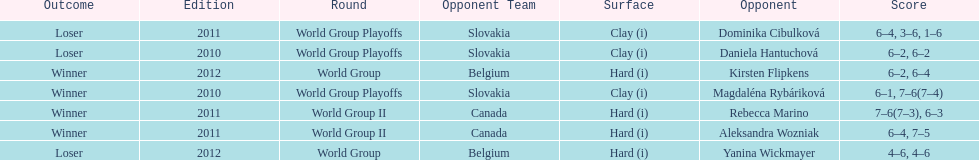What is the other year slovakia played besides 2010? 2011. Could you parse the entire table? {'header': ['Outcome', 'Edition', 'Round', 'Opponent Team', 'Surface', 'Opponent', 'Score'], 'rows': [['Loser', '2011', 'World Group Playoffs', 'Slovakia', 'Clay (i)', 'Dominika Cibulková', '6–4, 3–6, 1–6'], ['Loser', '2010', 'World Group Playoffs', 'Slovakia', 'Clay (i)', 'Daniela Hantuchová', '6–2, 6–2'], ['Winner', '2012', 'World Group', 'Belgium', 'Hard (i)', 'Kirsten Flipkens', '6–2, 6–4'], ['Winner', '2010', 'World Group Playoffs', 'Slovakia', 'Clay (i)', 'Magdaléna Rybáriková', '6–1, 7–6(7–4)'], ['Winner', '2011', 'World Group II', 'Canada', 'Hard (i)', 'Rebecca Marino', '7–6(7–3), 6–3'], ['Winner', '2011', 'World Group II', 'Canada', 'Hard (i)', 'Aleksandra Wozniak', '6–4, 7–5'], ['Loser', '2012', 'World Group', 'Belgium', 'Hard (i)', 'Yanina Wickmayer', '4–6, 4–6']]} 